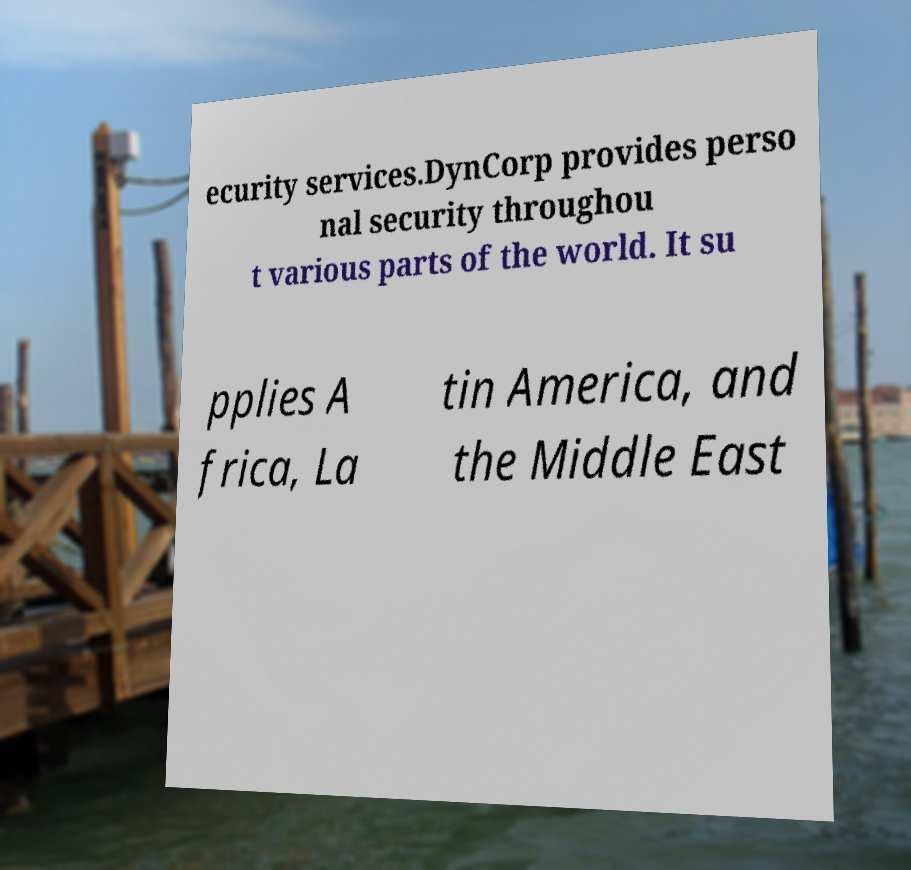Please identify and transcribe the text found in this image. ecurity services.DynCorp provides perso nal security throughou t various parts of the world. It su pplies A frica, La tin America, and the Middle East 